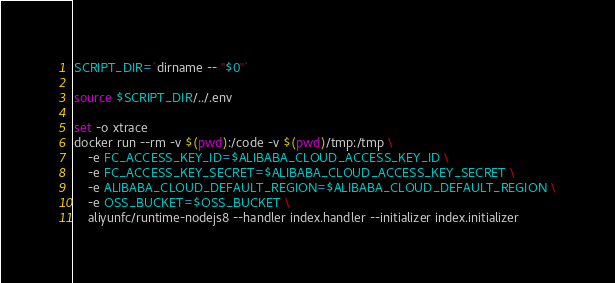<code> <loc_0><loc_0><loc_500><loc_500><_Bash_>SCRIPT_DIR=`dirname -- "$0"`

source $SCRIPT_DIR/../.env

set -o xtrace
docker run --rm -v $(pwd):/code -v $(pwd)/tmp:/tmp \
    -e FC_ACCESS_KEY_ID=$ALIBABA_CLOUD_ACCESS_KEY_ID \
    -e FC_ACCESS_KEY_SECRET=$ALIBABA_CLOUD_ACCESS_KEY_SECRET \
    -e ALIBABA_CLOUD_DEFAULT_REGION=$ALIBABA_CLOUD_DEFAULT_REGION \
    -e OSS_BUCKET=$OSS_BUCKET \
    aliyunfc/runtime-nodejs8 --handler index.handler --initializer index.initializer</code> 